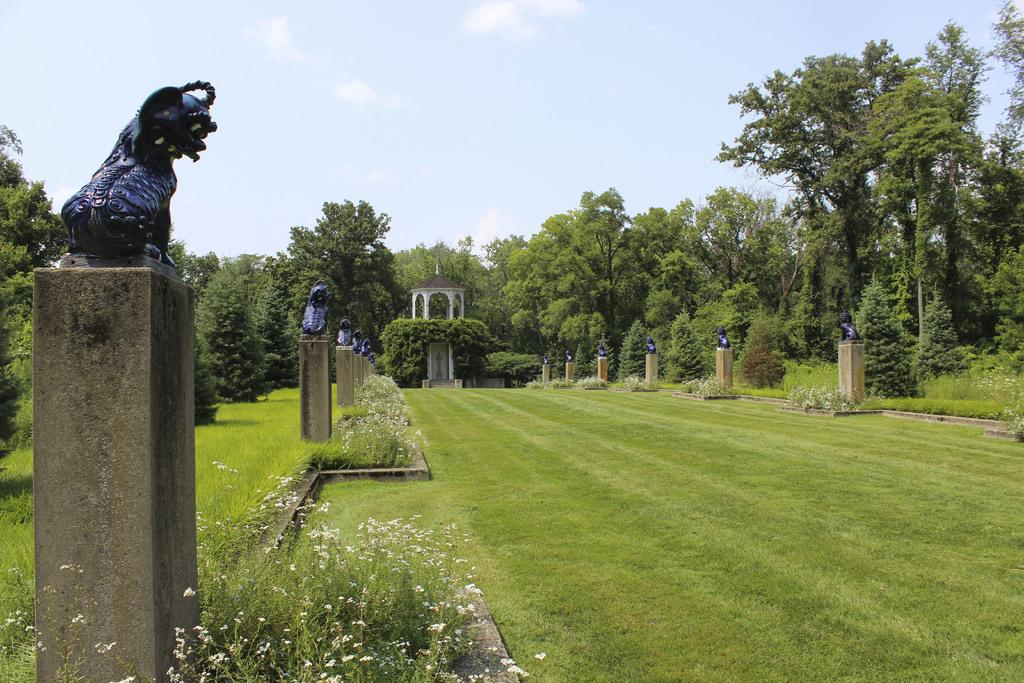What type of vegetation can be seen in the image? There is grass in the image. What architectural elements are present in the image? There are statues on pillars in the image. What type of plants with flowers are visible in the image? There are plants with flowers in the image. Can you describe the shaded area in the image? There is a shaded area in the image. What other natural elements can be seen in the image? There are trees in the image. What is visible in the background of the image? The sky is visible in the background of the image. What type of pies are being served in the shaded area of the image? There are no pies present in the image; it features statues on pillars, plants with flowers, trees, and a shaded area. What is the source of fear in the image? There is no indication of fear or any fear-inducing elements in the image. 